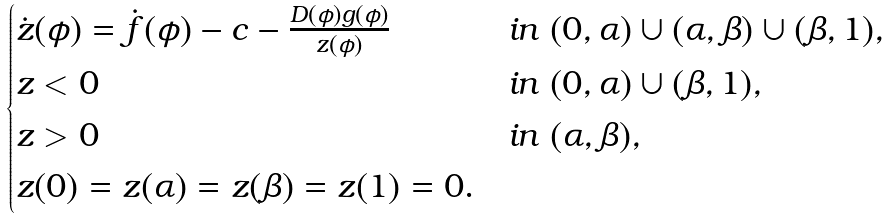Convert formula to latex. <formula><loc_0><loc_0><loc_500><loc_500>\begin{cases} \dot { z } ( \phi ) = \dot { f } ( \phi ) - c - \frac { D ( \phi ) g ( \phi ) } { z ( \phi ) } \ & i n \ ( 0 , \alpha ) \cup ( \alpha , \beta ) \cup ( \beta , 1 ) , \\ z < 0 \ & i n \ ( 0 , \alpha ) \cup ( \beta , 1 ) , \\ z > 0 \ & i n \ ( \alpha , \beta ) , \\ z ( 0 ) = z ( \alpha ) = z ( \beta ) = z ( 1 ) = 0 . \end{cases}</formula> 